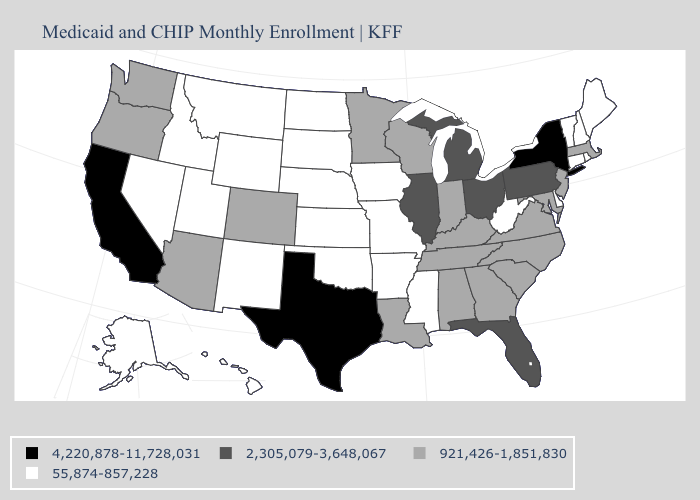Among the states that border Ohio , which have the lowest value?
Concise answer only. West Virginia. Name the states that have a value in the range 2,305,079-3,648,067?
Be succinct. Florida, Illinois, Michigan, Ohio, Pennsylvania. What is the highest value in the Northeast ?
Keep it brief. 4,220,878-11,728,031. Is the legend a continuous bar?
Keep it brief. No. Name the states that have a value in the range 55,874-857,228?
Be succinct. Alaska, Arkansas, Connecticut, Delaware, Hawaii, Idaho, Iowa, Kansas, Maine, Mississippi, Missouri, Montana, Nebraska, Nevada, New Hampshire, New Mexico, North Dakota, Oklahoma, Rhode Island, South Dakota, Utah, Vermont, West Virginia, Wyoming. Name the states that have a value in the range 4,220,878-11,728,031?
Keep it brief. California, New York, Texas. What is the value of Tennessee?
Keep it brief. 921,426-1,851,830. Name the states that have a value in the range 55,874-857,228?
Short answer required. Alaska, Arkansas, Connecticut, Delaware, Hawaii, Idaho, Iowa, Kansas, Maine, Mississippi, Missouri, Montana, Nebraska, Nevada, New Hampshire, New Mexico, North Dakota, Oklahoma, Rhode Island, South Dakota, Utah, Vermont, West Virginia, Wyoming. Does Tennessee have the lowest value in the USA?
Quick response, please. No. Among the states that border Colorado , which have the highest value?
Short answer required. Arizona. What is the highest value in the MidWest ?
Short answer required. 2,305,079-3,648,067. What is the highest value in states that border Oklahoma?
Write a very short answer. 4,220,878-11,728,031. Does the first symbol in the legend represent the smallest category?
Give a very brief answer. No. Does New York have the highest value in the Northeast?
Be succinct. Yes. 